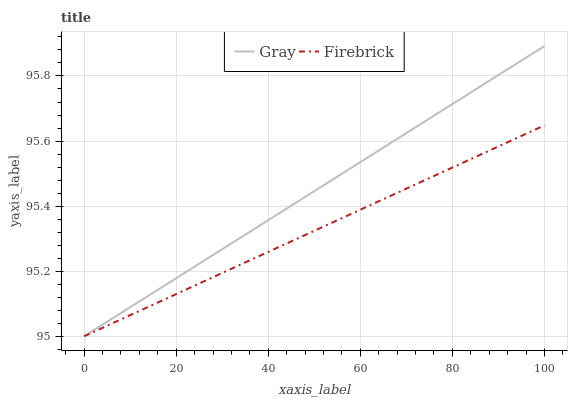Does Firebrick have the minimum area under the curve?
Answer yes or no. Yes. Does Gray have the maximum area under the curve?
Answer yes or no. Yes. Does Firebrick have the maximum area under the curve?
Answer yes or no. No. Is Firebrick the smoothest?
Answer yes or no. Yes. Is Gray the roughest?
Answer yes or no. Yes. Is Firebrick the roughest?
Answer yes or no. No. Does Gray have the lowest value?
Answer yes or no. Yes. Does Gray have the highest value?
Answer yes or no. Yes. Does Firebrick have the highest value?
Answer yes or no. No. Does Gray intersect Firebrick?
Answer yes or no. Yes. Is Gray less than Firebrick?
Answer yes or no. No. Is Gray greater than Firebrick?
Answer yes or no. No. 